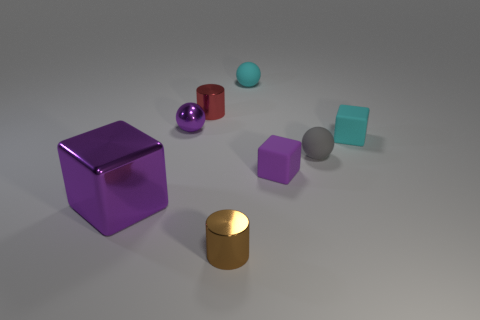Add 2 tiny cyan rubber things. How many objects exist? 10 Subtract all blocks. How many objects are left? 5 Subtract 0 yellow cylinders. How many objects are left? 8 Subtract all tiny matte cubes. Subtract all small brown metallic objects. How many objects are left? 5 Add 3 small gray rubber spheres. How many small gray rubber spheres are left? 4 Add 5 large purple blocks. How many large purple blocks exist? 6 